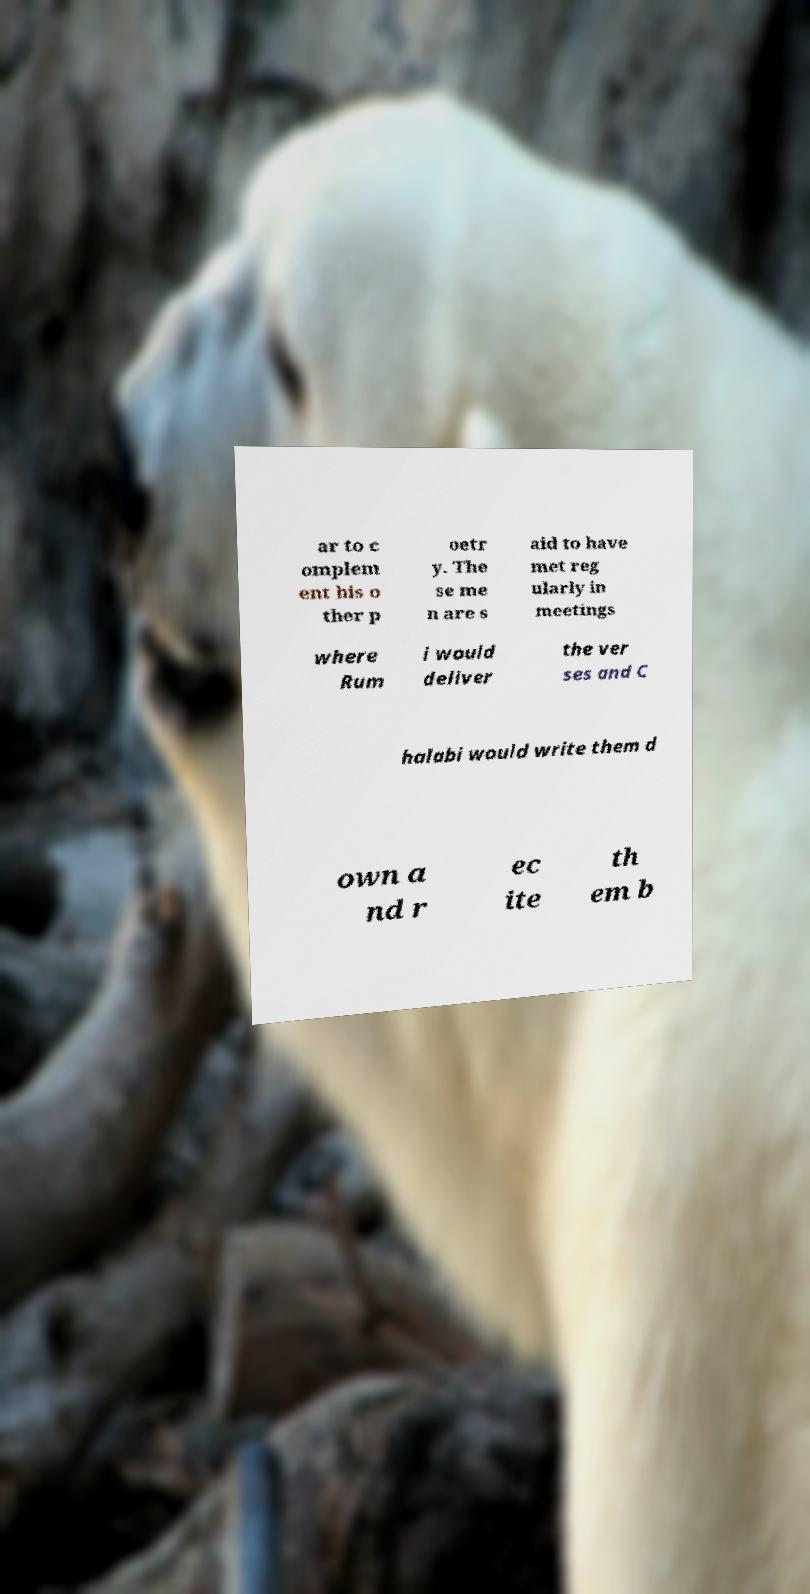Could you assist in decoding the text presented in this image and type it out clearly? ar to c omplem ent his o ther p oetr y. The se me n are s aid to have met reg ularly in meetings where Rum i would deliver the ver ses and C halabi would write them d own a nd r ec ite th em b 